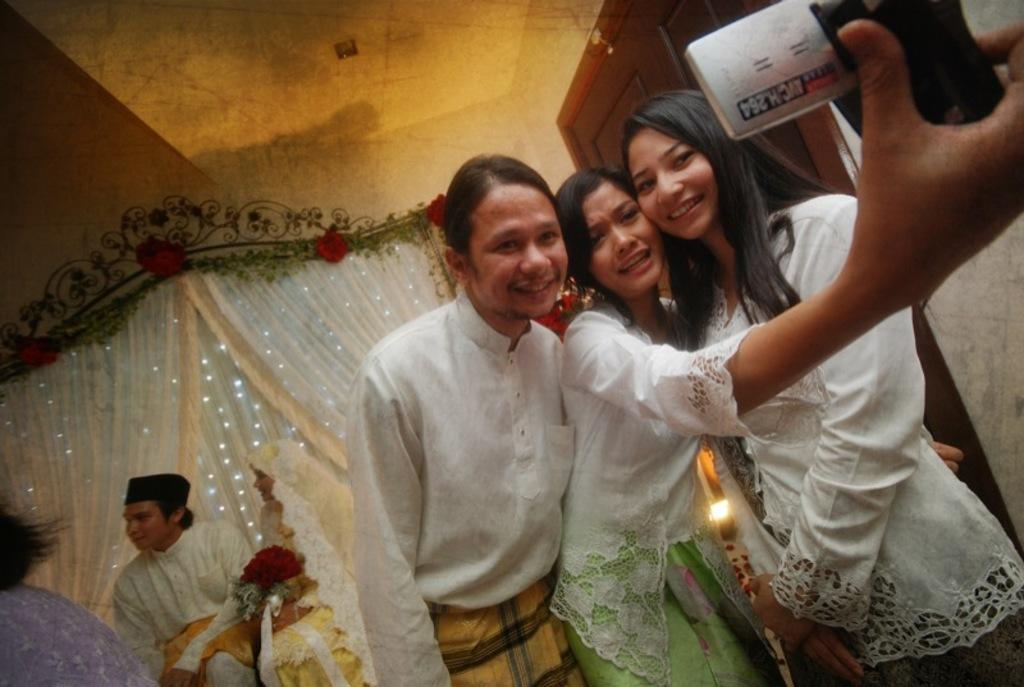Who or what can be seen in the image? There are people in the image. What type of window treatment is present in the image? There are curtains in the image. Is there any entrance or exit visible in the image? Yes, there is a door in the image. What provides illumination in the image? There is a light in the image. What structure covers the area in the image? There is a roof in the image. What separates the interior and exterior spaces in the image? There is a wall in the image. What type of map can be seen on someone's knee in the image? There is no map or knee visible in the image. 